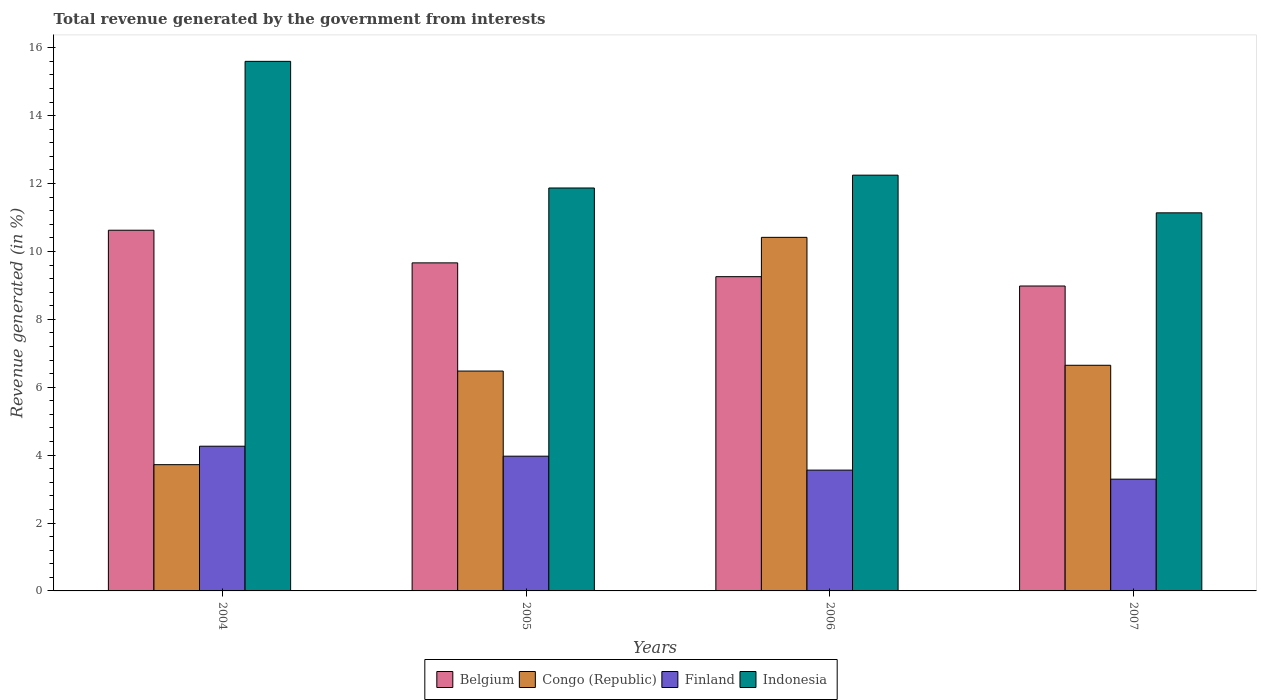Are the number of bars on each tick of the X-axis equal?
Offer a very short reply. Yes. How many bars are there on the 1st tick from the right?
Give a very brief answer. 4. What is the label of the 1st group of bars from the left?
Give a very brief answer. 2004. In how many cases, is the number of bars for a given year not equal to the number of legend labels?
Your response must be concise. 0. What is the total revenue generated in Indonesia in 2006?
Provide a succinct answer. 12.25. Across all years, what is the maximum total revenue generated in Belgium?
Ensure brevity in your answer.  10.62. Across all years, what is the minimum total revenue generated in Congo (Republic)?
Your answer should be very brief. 3.72. In which year was the total revenue generated in Belgium minimum?
Your answer should be very brief. 2007. What is the total total revenue generated in Finland in the graph?
Your answer should be very brief. 15.08. What is the difference between the total revenue generated in Indonesia in 2004 and that in 2005?
Make the answer very short. 3.73. What is the difference between the total revenue generated in Belgium in 2005 and the total revenue generated in Finland in 2006?
Your answer should be compact. 6.1. What is the average total revenue generated in Indonesia per year?
Provide a short and direct response. 12.71. In the year 2004, what is the difference between the total revenue generated in Finland and total revenue generated in Belgium?
Your answer should be very brief. -6.36. What is the ratio of the total revenue generated in Finland in 2006 to that in 2007?
Your response must be concise. 1.08. Is the total revenue generated in Indonesia in 2004 less than that in 2006?
Your answer should be very brief. No. What is the difference between the highest and the second highest total revenue generated in Congo (Republic)?
Give a very brief answer. 3.77. What is the difference between the highest and the lowest total revenue generated in Belgium?
Ensure brevity in your answer.  1.64. Is the sum of the total revenue generated in Congo (Republic) in 2004 and 2005 greater than the maximum total revenue generated in Finland across all years?
Ensure brevity in your answer.  Yes. Is it the case that in every year, the sum of the total revenue generated in Congo (Republic) and total revenue generated in Belgium is greater than the total revenue generated in Finland?
Your answer should be compact. Yes. How many bars are there?
Your answer should be compact. 16. How many years are there in the graph?
Make the answer very short. 4. Are the values on the major ticks of Y-axis written in scientific E-notation?
Your answer should be very brief. No. Does the graph contain grids?
Provide a succinct answer. No. How many legend labels are there?
Ensure brevity in your answer.  4. How are the legend labels stacked?
Offer a very short reply. Horizontal. What is the title of the graph?
Your answer should be very brief. Total revenue generated by the government from interests. Does "Congo (Democratic)" appear as one of the legend labels in the graph?
Your answer should be compact. No. What is the label or title of the X-axis?
Offer a very short reply. Years. What is the label or title of the Y-axis?
Keep it short and to the point. Revenue generated (in %). What is the Revenue generated (in %) of Belgium in 2004?
Offer a terse response. 10.62. What is the Revenue generated (in %) in Congo (Republic) in 2004?
Keep it short and to the point. 3.72. What is the Revenue generated (in %) in Finland in 2004?
Ensure brevity in your answer.  4.26. What is the Revenue generated (in %) in Indonesia in 2004?
Provide a short and direct response. 15.6. What is the Revenue generated (in %) of Belgium in 2005?
Your answer should be very brief. 9.66. What is the Revenue generated (in %) of Congo (Republic) in 2005?
Make the answer very short. 6.48. What is the Revenue generated (in %) in Finland in 2005?
Provide a short and direct response. 3.97. What is the Revenue generated (in %) of Indonesia in 2005?
Offer a terse response. 11.87. What is the Revenue generated (in %) in Belgium in 2006?
Give a very brief answer. 9.26. What is the Revenue generated (in %) of Congo (Republic) in 2006?
Keep it short and to the point. 10.41. What is the Revenue generated (in %) of Finland in 2006?
Provide a short and direct response. 3.56. What is the Revenue generated (in %) of Indonesia in 2006?
Offer a very short reply. 12.25. What is the Revenue generated (in %) of Belgium in 2007?
Offer a very short reply. 8.98. What is the Revenue generated (in %) in Congo (Republic) in 2007?
Your response must be concise. 6.65. What is the Revenue generated (in %) in Finland in 2007?
Make the answer very short. 3.29. What is the Revenue generated (in %) in Indonesia in 2007?
Make the answer very short. 11.14. Across all years, what is the maximum Revenue generated (in %) of Belgium?
Ensure brevity in your answer.  10.62. Across all years, what is the maximum Revenue generated (in %) in Congo (Republic)?
Provide a short and direct response. 10.41. Across all years, what is the maximum Revenue generated (in %) in Finland?
Offer a terse response. 4.26. Across all years, what is the maximum Revenue generated (in %) in Indonesia?
Your answer should be compact. 15.6. Across all years, what is the minimum Revenue generated (in %) in Belgium?
Ensure brevity in your answer.  8.98. Across all years, what is the minimum Revenue generated (in %) in Congo (Republic)?
Offer a very short reply. 3.72. Across all years, what is the minimum Revenue generated (in %) in Finland?
Your answer should be very brief. 3.29. Across all years, what is the minimum Revenue generated (in %) of Indonesia?
Offer a very short reply. 11.14. What is the total Revenue generated (in %) in Belgium in the graph?
Give a very brief answer. 38.52. What is the total Revenue generated (in %) of Congo (Republic) in the graph?
Provide a short and direct response. 27.26. What is the total Revenue generated (in %) of Finland in the graph?
Provide a succinct answer. 15.08. What is the total Revenue generated (in %) of Indonesia in the graph?
Keep it short and to the point. 50.85. What is the difference between the Revenue generated (in %) of Belgium in 2004 and that in 2005?
Provide a short and direct response. 0.96. What is the difference between the Revenue generated (in %) of Congo (Republic) in 2004 and that in 2005?
Provide a succinct answer. -2.76. What is the difference between the Revenue generated (in %) in Finland in 2004 and that in 2005?
Offer a very short reply. 0.29. What is the difference between the Revenue generated (in %) in Indonesia in 2004 and that in 2005?
Your response must be concise. 3.73. What is the difference between the Revenue generated (in %) of Belgium in 2004 and that in 2006?
Provide a succinct answer. 1.37. What is the difference between the Revenue generated (in %) of Congo (Republic) in 2004 and that in 2006?
Make the answer very short. -6.7. What is the difference between the Revenue generated (in %) of Finland in 2004 and that in 2006?
Provide a succinct answer. 0.7. What is the difference between the Revenue generated (in %) in Indonesia in 2004 and that in 2006?
Offer a terse response. 3.35. What is the difference between the Revenue generated (in %) in Belgium in 2004 and that in 2007?
Make the answer very short. 1.64. What is the difference between the Revenue generated (in %) in Congo (Republic) in 2004 and that in 2007?
Provide a short and direct response. -2.93. What is the difference between the Revenue generated (in %) of Finland in 2004 and that in 2007?
Your answer should be very brief. 0.97. What is the difference between the Revenue generated (in %) in Indonesia in 2004 and that in 2007?
Your answer should be very brief. 4.46. What is the difference between the Revenue generated (in %) of Belgium in 2005 and that in 2006?
Your answer should be very brief. 0.41. What is the difference between the Revenue generated (in %) of Congo (Republic) in 2005 and that in 2006?
Ensure brevity in your answer.  -3.94. What is the difference between the Revenue generated (in %) in Finland in 2005 and that in 2006?
Keep it short and to the point. 0.41. What is the difference between the Revenue generated (in %) of Indonesia in 2005 and that in 2006?
Provide a short and direct response. -0.38. What is the difference between the Revenue generated (in %) in Belgium in 2005 and that in 2007?
Provide a succinct answer. 0.68. What is the difference between the Revenue generated (in %) of Congo (Republic) in 2005 and that in 2007?
Your answer should be compact. -0.17. What is the difference between the Revenue generated (in %) in Finland in 2005 and that in 2007?
Offer a terse response. 0.68. What is the difference between the Revenue generated (in %) in Indonesia in 2005 and that in 2007?
Offer a very short reply. 0.73. What is the difference between the Revenue generated (in %) of Belgium in 2006 and that in 2007?
Provide a short and direct response. 0.28. What is the difference between the Revenue generated (in %) in Congo (Republic) in 2006 and that in 2007?
Provide a short and direct response. 3.77. What is the difference between the Revenue generated (in %) in Finland in 2006 and that in 2007?
Your answer should be very brief. 0.27. What is the difference between the Revenue generated (in %) of Indonesia in 2006 and that in 2007?
Your response must be concise. 1.11. What is the difference between the Revenue generated (in %) of Belgium in 2004 and the Revenue generated (in %) of Congo (Republic) in 2005?
Your answer should be compact. 4.15. What is the difference between the Revenue generated (in %) of Belgium in 2004 and the Revenue generated (in %) of Finland in 2005?
Offer a very short reply. 6.66. What is the difference between the Revenue generated (in %) in Belgium in 2004 and the Revenue generated (in %) in Indonesia in 2005?
Offer a terse response. -1.24. What is the difference between the Revenue generated (in %) of Congo (Republic) in 2004 and the Revenue generated (in %) of Finland in 2005?
Keep it short and to the point. -0.25. What is the difference between the Revenue generated (in %) of Congo (Republic) in 2004 and the Revenue generated (in %) of Indonesia in 2005?
Offer a very short reply. -8.15. What is the difference between the Revenue generated (in %) in Finland in 2004 and the Revenue generated (in %) in Indonesia in 2005?
Your answer should be very brief. -7.61. What is the difference between the Revenue generated (in %) of Belgium in 2004 and the Revenue generated (in %) of Congo (Republic) in 2006?
Keep it short and to the point. 0.21. What is the difference between the Revenue generated (in %) in Belgium in 2004 and the Revenue generated (in %) in Finland in 2006?
Give a very brief answer. 7.07. What is the difference between the Revenue generated (in %) in Belgium in 2004 and the Revenue generated (in %) in Indonesia in 2006?
Ensure brevity in your answer.  -1.62. What is the difference between the Revenue generated (in %) in Congo (Republic) in 2004 and the Revenue generated (in %) in Finland in 2006?
Ensure brevity in your answer.  0.16. What is the difference between the Revenue generated (in %) in Congo (Republic) in 2004 and the Revenue generated (in %) in Indonesia in 2006?
Your answer should be very brief. -8.53. What is the difference between the Revenue generated (in %) of Finland in 2004 and the Revenue generated (in %) of Indonesia in 2006?
Give a very brief answer. -7.98. What is the difference between the Revenue generated (in %) in Belgium in 2004 and the Revenue generated (in %) in Congo (Republic) in 2007?
Provide a succinct answer. 3.98. What is the difference between the Revenue generated (in %) in Belgium in 2004 and the Revenue generated (in %) in Finland in 2007?
Keep it short and to the point. 7.33. What is the difference between the Revenue generated (in %) of Belgium in 2004 and the Revenue generated (in %) of Indonesia in 2007?
Keep it short and to the point. -0.51. What is the difference between the Revenue generated (in %) in Congo (Republic) in 2004 and the Revenue generated (in %) in Finland in 2007?
Offer a terse response. 0.43. What is the difference between the Revenue generated (in %) of Congo (Republic) in 2004 and the Revenue generated (in %) of Indonesia in 2007?
Provide a succinct answer. -7.42. What is the difference between the Revenue generated (in %) of Finland in 2004 and the Revenue generated (in %) of Indonesia in 2007?
Ensure brevity in your answer.  -6.87. What is the difference between the Revenue generated (in %) of Belgium in 2005 and the Revenue generated (in %) of Congo (Republic) in 2006?
Your answer should be very brief. -0.75. What is the difference between the Revenue generated (in %) in Belgium in 2005 and the Revenue generated (in %) in Finland in 2006?
Provide a succinct answer. 6.1. What is the difference between the Revenue generated (in %) in Belgium in 2005 and the Revenue generated (in %) in Indonesia in 2006?
Make the answer very short. -2.58. What is the difference between the Revenue generated (in %) of Congo (Republic) in 2005 and the Revenue generated (in %) of Finland in 2006?
Ensure brevity in your answer.  2.92. What is the difference between the Revenue generated (in %) in Congo (Republic) in 2005 and the Revenue generated (in %) in Indonesia in 2006?
Your answer should be very brief. -5.77. What is the difference between the Revenue generated (in %) in Finland in 2005 and the Revenue generated (in %) in Indonesia in 2006?
Your answer should be very brief. -8.28. What is the difference between the Revenue generated (in %) in Belgium in 2005 and the Revenue generated (in %) in Congo (Republic) in 2007?
Your response must be concise. 3.02. What is the difference between the Revenue generated (in %) of Belgium in 2005 and the Revenue generated (in %) of Finland in 2007?
Offer a terse response. 6.37. What is the difference between the Revenue generated (in %) of Belgium in 2005 and the Revenue generated (in %) of Indonesia in 2007?
Give a very brief answer. -1.47. What is the difference between the Revenue generated (in %) in Congo (Republic) in 2005 and the Revenue generated (in %) in Finland in 2007?
Your answer should be compact. 3.18. What is the difference between the Revenue generated (in %) in Congo (Republic) in 2005 and the Revenue generated (in %) in Indonesia in 2007?
Give a very brief answer. -4.66. What is the difference between the Revenue generated (in %) in Finland in 2005 and the Revenue generated (in %) in Indonesia in 2007?
Keep it short and to the point. -7.17. What is the difference between the Revenue generated (in %) in Belgium in 2006 and the Revenue generated (in %) in Congo (Republic) in 2007?
Your answer should be compact. 2.61. What is the difference between the Revenue generated (in %) in Belgium in 2006 and the Revenue generated (in %) in Finland in 2007?
Your answer should be very brief. 5.96. What is the difference between the Revenue generated (in %) of Belgium in 2006 and the Revenue generated (in %) of Indonesia in 2007?
Give a very brief answer. -1.88. What is the difference between the Revenue generated (in %) of Congo (Republic) in 2006 and the Revenue generated (in %) of Finland in 2007?
Provide a succinct answer. 7.12. What is the difference between the Revenue generated (in %) of Congo (Republic) in 2006 and the Revenue generated (in %) of Indonesia in 2007?
Ensure brevity in your answer.  -0.72. What is the difference between the Revenue generated (in %) in Finland in 2006 and the Revenue generated (in %) in Indonesia in 2007?
Ensure brevity in your answer.  -7.58. What is the average Revenue generated (in %) in Belgium per year?
Keep it short and to the point. 9.63. What is the average Revenue generated (in %) in Congo (Republic) per year?
Provide a succinct answer. 6.81. What is the average Revenue generated (in %) in Finland per year?
Keep it short and to the point. 3.77. What is the average Revenue generated (in %) in Indonesia per year?
Keep it short and to the point. 12.71. In the year 2004, what is the difference between the Revenue generated (in %) in Belgium and Revenue generated (in %) in Congo (Republic)?
Give a very brief answer. 6.91. In the year 2004, what is the difference between the Revenue generated (in %) in Belgium and Revenue generated (in %) in Finland?
Provide a short and direct response. 6.36. In the year 2004, what is the difference between the Revenue generated (in %) in Belgium and Revenue generated (in %) in Indonesia?
Give a very brief answer. -4.97. In the year 2004, what is the difference between the Revenue generated (in %) of Congo (Republic) and Revenue generated (in %) of Finland?
Provide a succinct answer. -0.54. In the year 2004, what is the difference between the Revenue generated (in %) in Congo (Republic) and Revenue generated (in %) in Indonesia?
Your answer should be compact. -11.88. In the year 2004, what is the difference between the Revenue generated (in %) in Finland and Revenue generated (in %) in Indonesia?
Offer a terse response. -11.34. In the year 2005, what is the difference between the Revenue generated (in %) in Belgium and Revenue generated (in %) in Congo (Republic)?
Offer a terse response. 3.19. In the year 2005, what is the difference between the Revenue generated (in %) in Belgium and Revenue generated (in %) in Finland?
Provide a short and direct response. 5.69. In the year 2005, what is the difference between the Revenue generated (in %) in Belgium and Revenue generated (in %) in Indonesia?
Provide a short and direct response. -2.21. In the year 2005, what is the difference between the Revenue generated (in %) in Congo (Republic) and Revenue generated (in %) in Finland?
Your response must be concise. 2.51. In the year 2005, what is the difference between the Revenue generated (in %) of Congo (Republic) and Revenue generated (in %) of Indonesia?
Make the answer very short. -5.39. In the year 2005, what is the difference between the Revenue generated (in %) in Finland and Revenue generated (in %) in Indonesia?
Offer a terse response. -7.9. In the year 2006, what is the difference between the Revenue generated (in %) of Belgium and Revenue generated (in %) of Congo (Republic)?
Your answer should be very brief. -1.16. In the year 2006, what is the difference between the Revenue generated (in %) of Belgium and Revenue generated (in %) of Finland?
Provide a short and direct response. 5.7. In the year 2006, what is the difference between the Revenue generated (in %) of Belgium and Revenue generated (in %) of Indonesia?
Your response must be concise. -2.99. In the year 2006, what is the difference between the Revenue generated (in %) of Congo (Republic) and Revenue generated (in %) of Finland?
Your response must be concise. 6.86. In the year 2006, what is the difference between the Revenue generated (in %) in Congo (Republic) and Revenue generated (in %) in Indonesia?
Offer a terse response. -1.83. In the year 2006, what is the difference between the Revenue generated (in %) in Finland and Revenue generated (in %) in Indonesia?
Give a very brief answer. -8.69. In the year 2007, what is the difference between the Revenue generated (in %) of Belgium and Revenue generated (in %) of Congo (Republic)?
Offer a terse response. 2.33. In the year 2007, what is the difference between the Revenue generated (in %) of Belgium and Revenue generated (in %) of Finland?
Your answer should be very brief. 5.69. In the year 2007, what is the difference between the Revenue generated (in %) of Belgium and Revenue generated (in %) of Indonesia?
Your answer should be very brief. -2.16. In the year 2007, what is the difference between the Revenue generated (in %) of Congo (Republic) and Revenue generated (in %) of Finland?
Ensure brevity in your answer.  3.35. In the year 2007, what is the difference between the Revenue generated (in %) in Congo (Republic) and Revenue generated (in %) in Indonesia?
Provide a short and direct response. -4.49. In the year 2007, what is the difference between the Revenue generated (in %) of Finland and Revenue generated (in %) of Indonesia?
Offer a terse response. -7.84. What is the ratio of the Revenue generated (in %) in Belgium in 2004 to that in 2005?
Your answer should be compact. 1.1. What is the ratio of the Revenue generated (in %) of Congo (Republic) in 2004 to that in 2005?
Provide a succinct answer. 0.57. What is the ratio of the Revenue generated (in %) of Finland in 2004 to that in 2005?
Provide a short and direct response. 1.07. What is the ratio of the Revenue generated (in %) in Indonesia in 2004 to that in 2005?
Give a very brief answer. 1.31. What is the ratio of the Revenue generated (in %) of Belgium in 2004 to that in 2006?
Provide a succinct answer. 1.15. What is the ratio of the Revenue generated (in %) in Congo (Republic) in 2004 to that in 2006?
Provide a succinct answer. 0.36. What is the ratio of the Revenue generated (in %) of Finland in 2004 to that in 2006?
Offer a very short reply. 1.2. What is the ratio of the Revenue generated (in %) of Indonesia in 2004 to that in 2006?
Make the answer very short. 1.27. What is the ratio of the Revenue generated (in %) of Belgium in 2004 to that in 2007?
Offer a terse response. 1.18. What is the ratio of the Revenue generated (in %) of Congo (Republic) in 2004 to that in 2007?
Your response must be concise. 0.56. What is the ratio of the Revenue generated (in %) in Finland in 2004 to that in 2007?
Your answer should be compact. 1.29. What is the ratio of the Revenue generated (in %) of Indonesia in 2004 to that in 2007?
Keep it short and to the point. 1.4. What is the ratio of the Revenue generated (in %) of Belgium in 2005 to that in 2006?
Offer a terse response. 1.04. What is the ratio of the Revenue generated (in %) of Congo (Republic) in 2005 to that in 2006?
Give a very brief answer. 0.62. What is the ratio of the Revenue generated (in %) in Finland in 2005 to that in 2006?
Ensure brevity in your answer.  1.12. What is the ratio of the Revenue generated (in %) of Indonesia in 2005 to that in 2006?
Provide a succinct answer. 0.97. What is the ratio of the Revenue generated (in %) of Belgium in 2005 to that in 2007?
Offer a terse response. 1.08. What is the ratio of the Revenue generated (in %) in Congo (Republic) in 2005 to that in 2007?
Offer a terse response. 0.97. What is the ratio of the Revenue generated (in %) in Finland in 2005 to that in 2007?
Provide a short and direct response. 1.21. What is the ratio of the Revenue generated (in %) in Indonesia in 2005 to that in 2007?
Provide a short and direct response. 1.07. What is the ratio of the Revenue generated (in %) of Belgium in 2006 to that in 2007?
Provide a short and direct response. 1.03. What is the ratio of the Revenue generated (in %) in Congo (Republic) in 2006 to that in 2007?
Keep it short and to the point. 1.57. What is the ratio of the Revenue generated (in %) in Finland in 2006 to that in 2007?
Provide a succinct answer. 1.08. What is the ratio of the Revenue generated (in %) in Indonesia in 2006 to that in 2007?
Make the answer very short. 1.1. What is the difference between the highest and the second highest Revenue generated (in %) of Belgium?
Your answer should be compact. 0.96. What is the difference between the highest and the second highest Revenue generated (in %) of Congo (Republic)?
Ensure brevity in your answer.  3.77. What is the difference between the highest and the second highest Revenue generated (in %) in Finland?
Ensure brevity in your answer.  0.29. What is the difference between the highest and the second highest Revenue generated (in %) of Indonesia?
Offer a terse response. 3.35. What is the difference between the highest and the lowest Revenue generated (in %) of Belgium?
Your answer should be very brief. 1.64. What is the difference between the highest and the lowest Revenue generated (in %) in Congo (Republic)?
Your answer should be very brief. 6.7. What is the difference between the highest and the lowest Revenue generated (in %) in Finland?
Provide a succinct answer. 0.97. What is the difference between the highest and the lowest Revenue generated (in %) of Indonesia?
Keep it short and to the point. 4.46. 